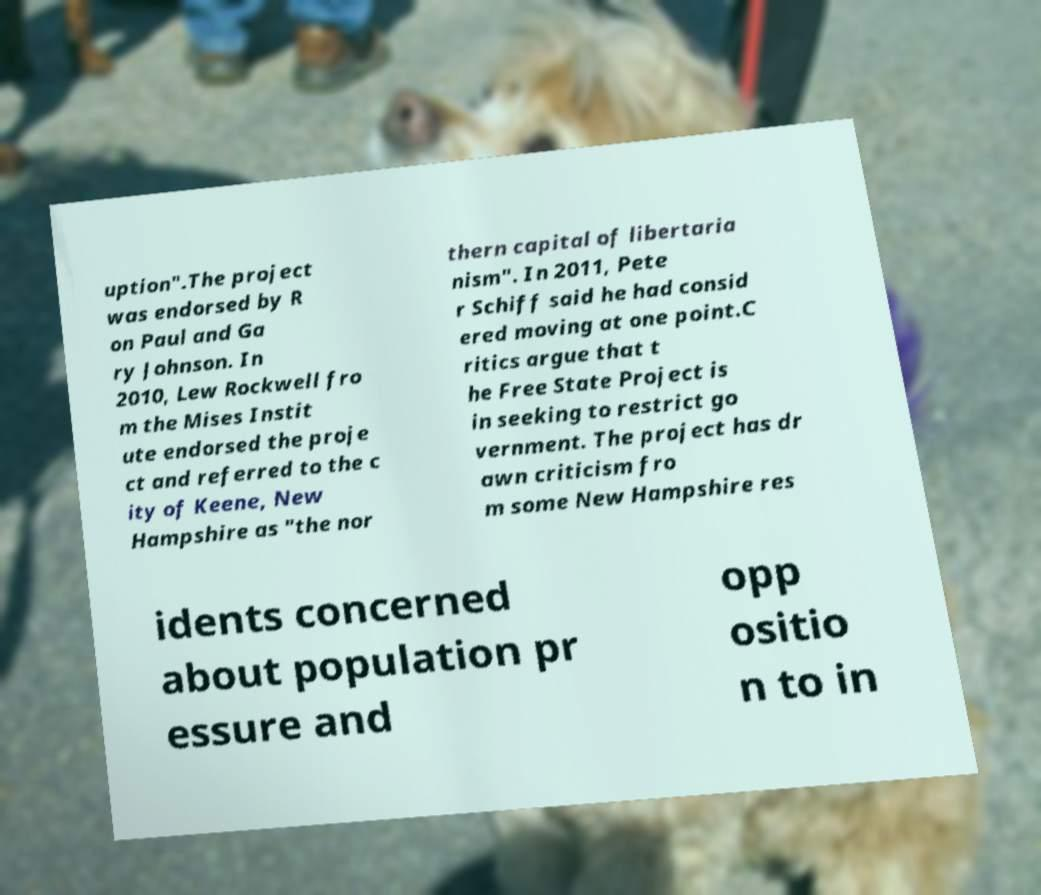Could you assist in decoding the text presented in this image and type it out clearly? uption".The project was endorsed by R on Paul and Ga ry Johnson. In 2010, Lew Rockwell fro m the Mises Instit ute endorsed the proje ct and referred to the c ity of Keene, New Hampshire as "the nor thern capital of libertaria nism". In 2011, Pete r Schiff said he had consid ered moving at one point.C ritics argue that t he Free State Project is in seeking to restrict go vernment. The project has dr awn criticism fro m some New Hampshire res idents concerned about population pr essure and opp ositio n to in 